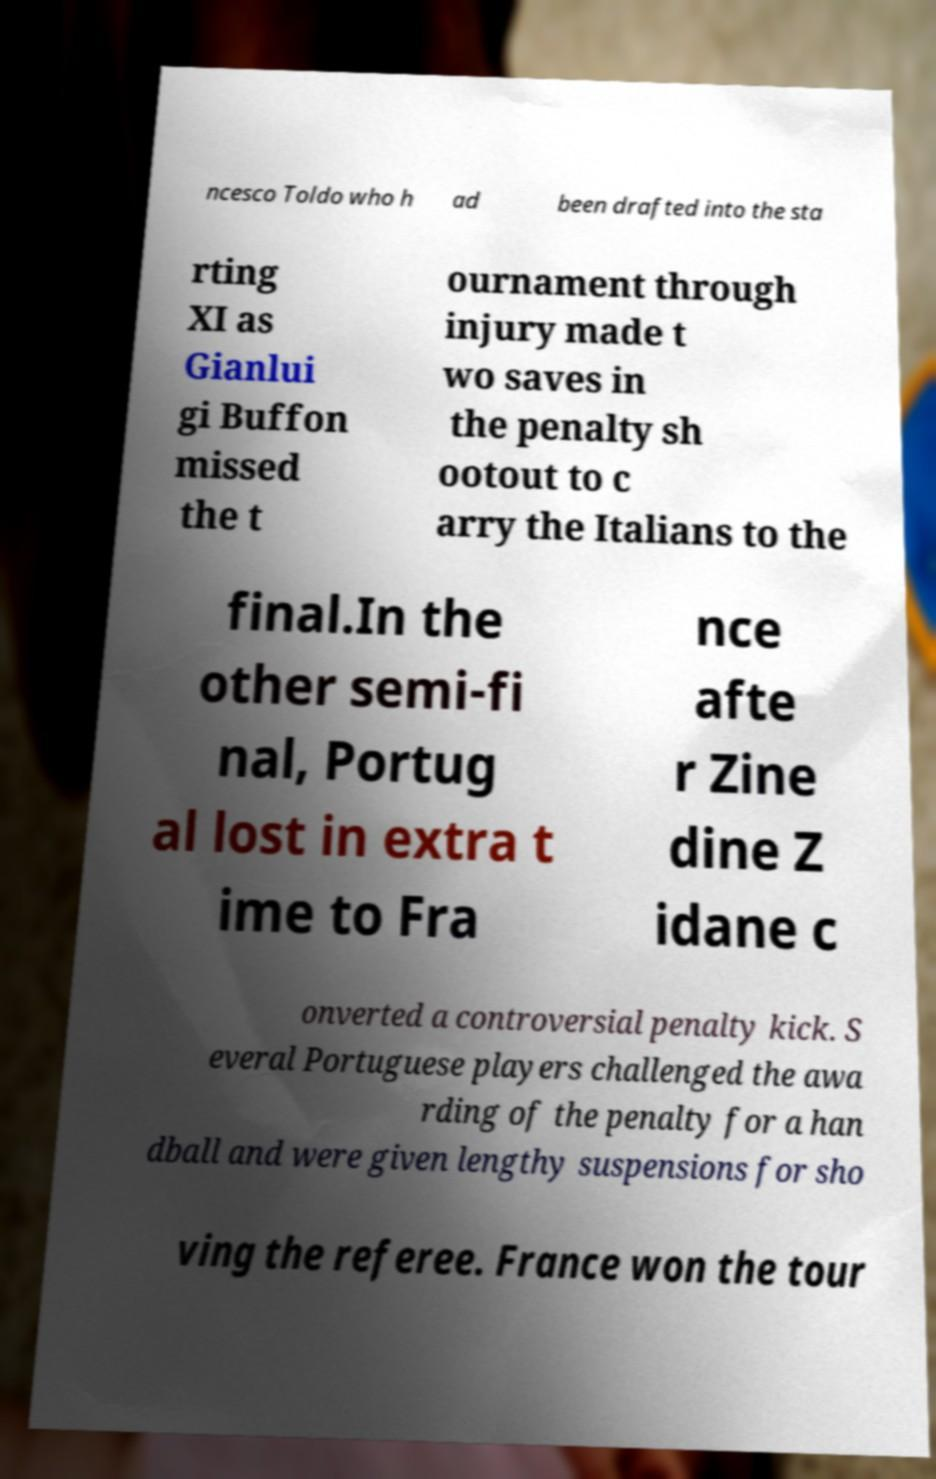Could you extract and type out the text from this image? ncesco Toldo who h ad been drafted into the sta rting XI as Gianlui gi Buffon missed the t ournament through injury made t wo saves in the penalty sh ootout to c arry the Italians to the final.In the other semi-fi nal, Portug al lost in extra t ime to Fra nce afte r Zine dine Z idane c onverted a controversial penalty kick. S everal Portuguese players challenged the awa rding of the penalty for a han dball and were given lengthy suspensions for sho ving the referee. France won the tour 